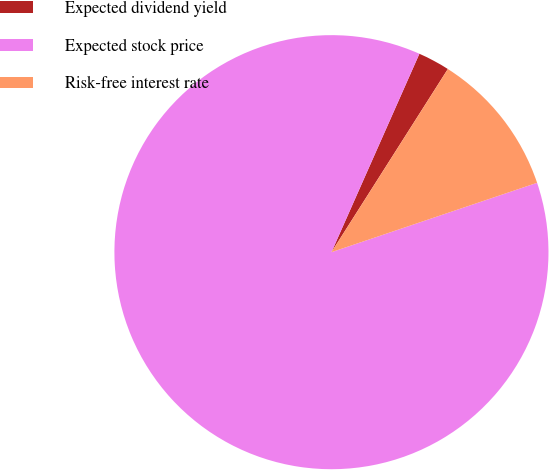Convert chart to OTSL. <chart><loc_0><loc_0><loc_500><loc_500><pie_chart><fcel>Expected dividend yield<fcel>Expected stock price<fcel>Risk-free interest rate<nl><fcel>2.37%<fcel>86.82%<fcel>10.81%<nl></chart> 